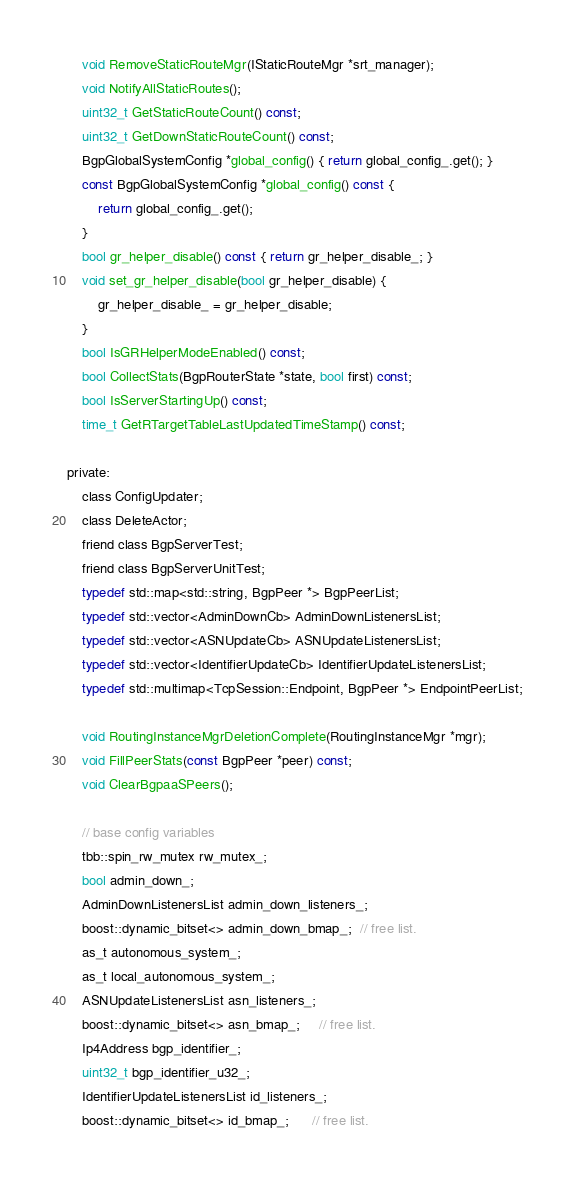<code> <loc_0><loc_0><loc_500><loc_500><_C_>    void RemoveStaticRouteMgr(IStaticRouteMgr *srt_manager);
    void NotifyAllStaticRoutes();
    uint32_t GetStaticRouteCount() const;
    uint32_t GetDownStaticRouteCount() const;
    BgpGlobalSystemConfig *global_config() { return global_config_.get(); }
    const BgpGlobalSystemConfig *global_config() const {
        return global_config_.get();
    }
    bool gr_helper_disable() const { return gr_helper_disable_; }
    void set_gr_helper_disable(bool gr_helper_disable) {
        gr_helper_disable_ = gr_helper_disable;
    }
    bool IsGRHelperModeEnabled() const;
    bool CollectStats(BgpRouterState *state, bool first) const;
    bool IsServerStartingUp() const;
    time_t GetRTargetTableLastUpdatedTimeStamp() const;

private:
    class ConfigUpdater;
    class DeleteActor;
    friend class BgpServerTest;
    friend class BgpServerUnitTest;
    typedef std::map<std::string, BgpPeer *> BgpPeerList;
    typedef std::vector<AdminDownCb> AdminDownListenersList;
    typedef std::vector<ASNUpdateCb> ASNUpdateListenersList;
    typedef std::vector<IdentifierUpdateCb> IdentifierUpdateListenersList;
    typedef std::multimap<TcpSession::Endpoint, BgpPeer *> EndpointPeerList;

    void RoutingInstanceMgrDeletionComplete(RoutingInstanceMgr *mgr);
    void FillPeerStats(const BgpPeer *peer) const;
    void ClearBgpaaSPeers();

    // base config variables
    tbb::spin_rw_mutex rw_mutex_;
    bool admin_down_;
    AdminDownListenersList admin_down_listeners_;
    boost::dynamic_bitset<> admin_down_bmap_;  // free list.
    as_t autonomous_system_;
    as_t local_autonomous_system_;
    ASNUpdateListenersList asn_listeners_;
    boost::dynamic_bitset<> asn_bmap_;     // free list.
    Ip4Address bgp_identifier_;
    uint32_t bgp_identifier_u32_;
    IdentifierUpdateListenersList id_listeners_;
    boost::dynamic_bitset<> id_bmap_;      // free list.</code> 